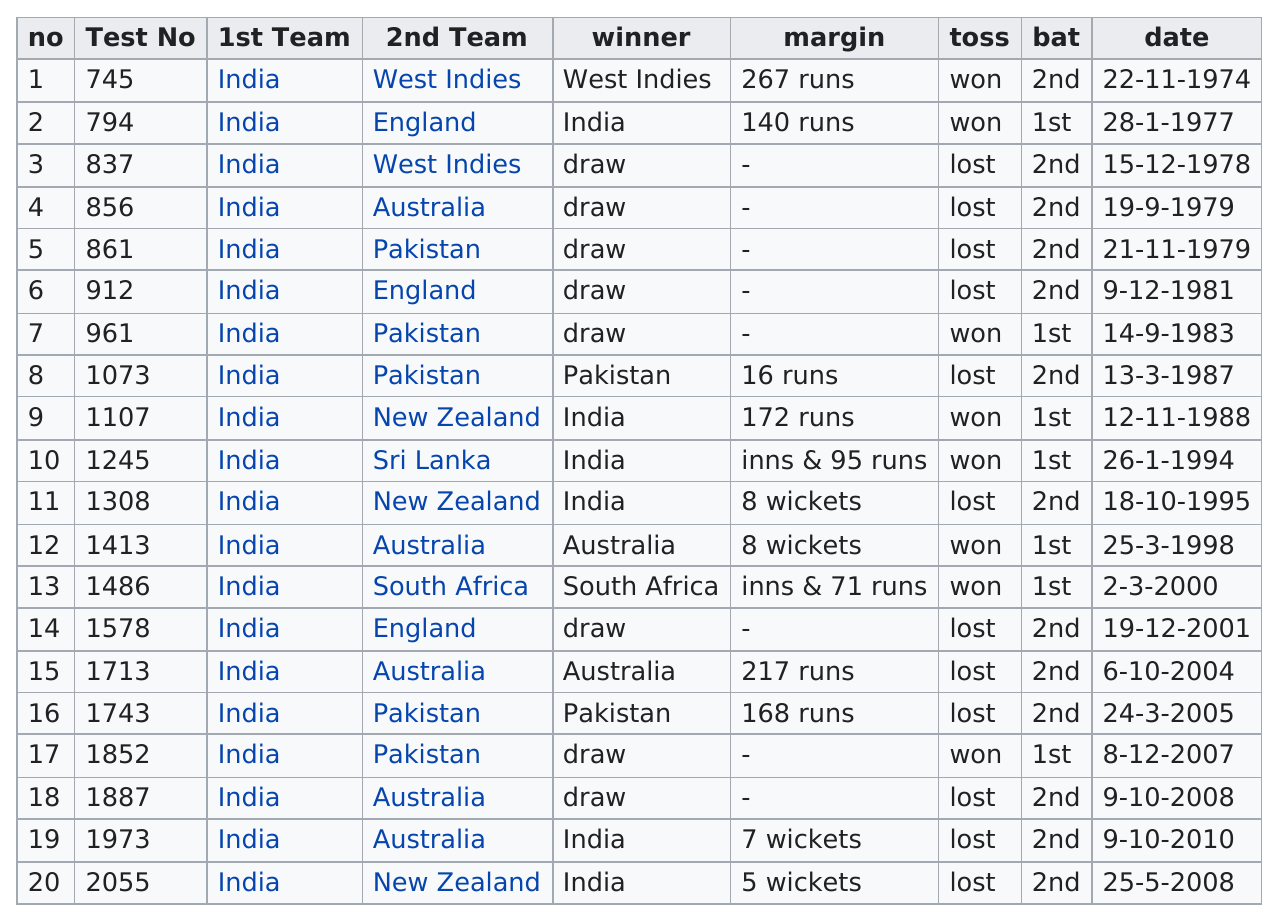Draw attention to some important aspects in this diagram. Prior to 1979, India, West Indies, and England were among the teams that played against each other in various cricket matches. Pakistan had the most draws against India in team competitions. There have been a total of 8 heads that have been won in the coin toss. Other than India, Australia is the country that has won the most Test matches. The number of runs scored in each number is different. 